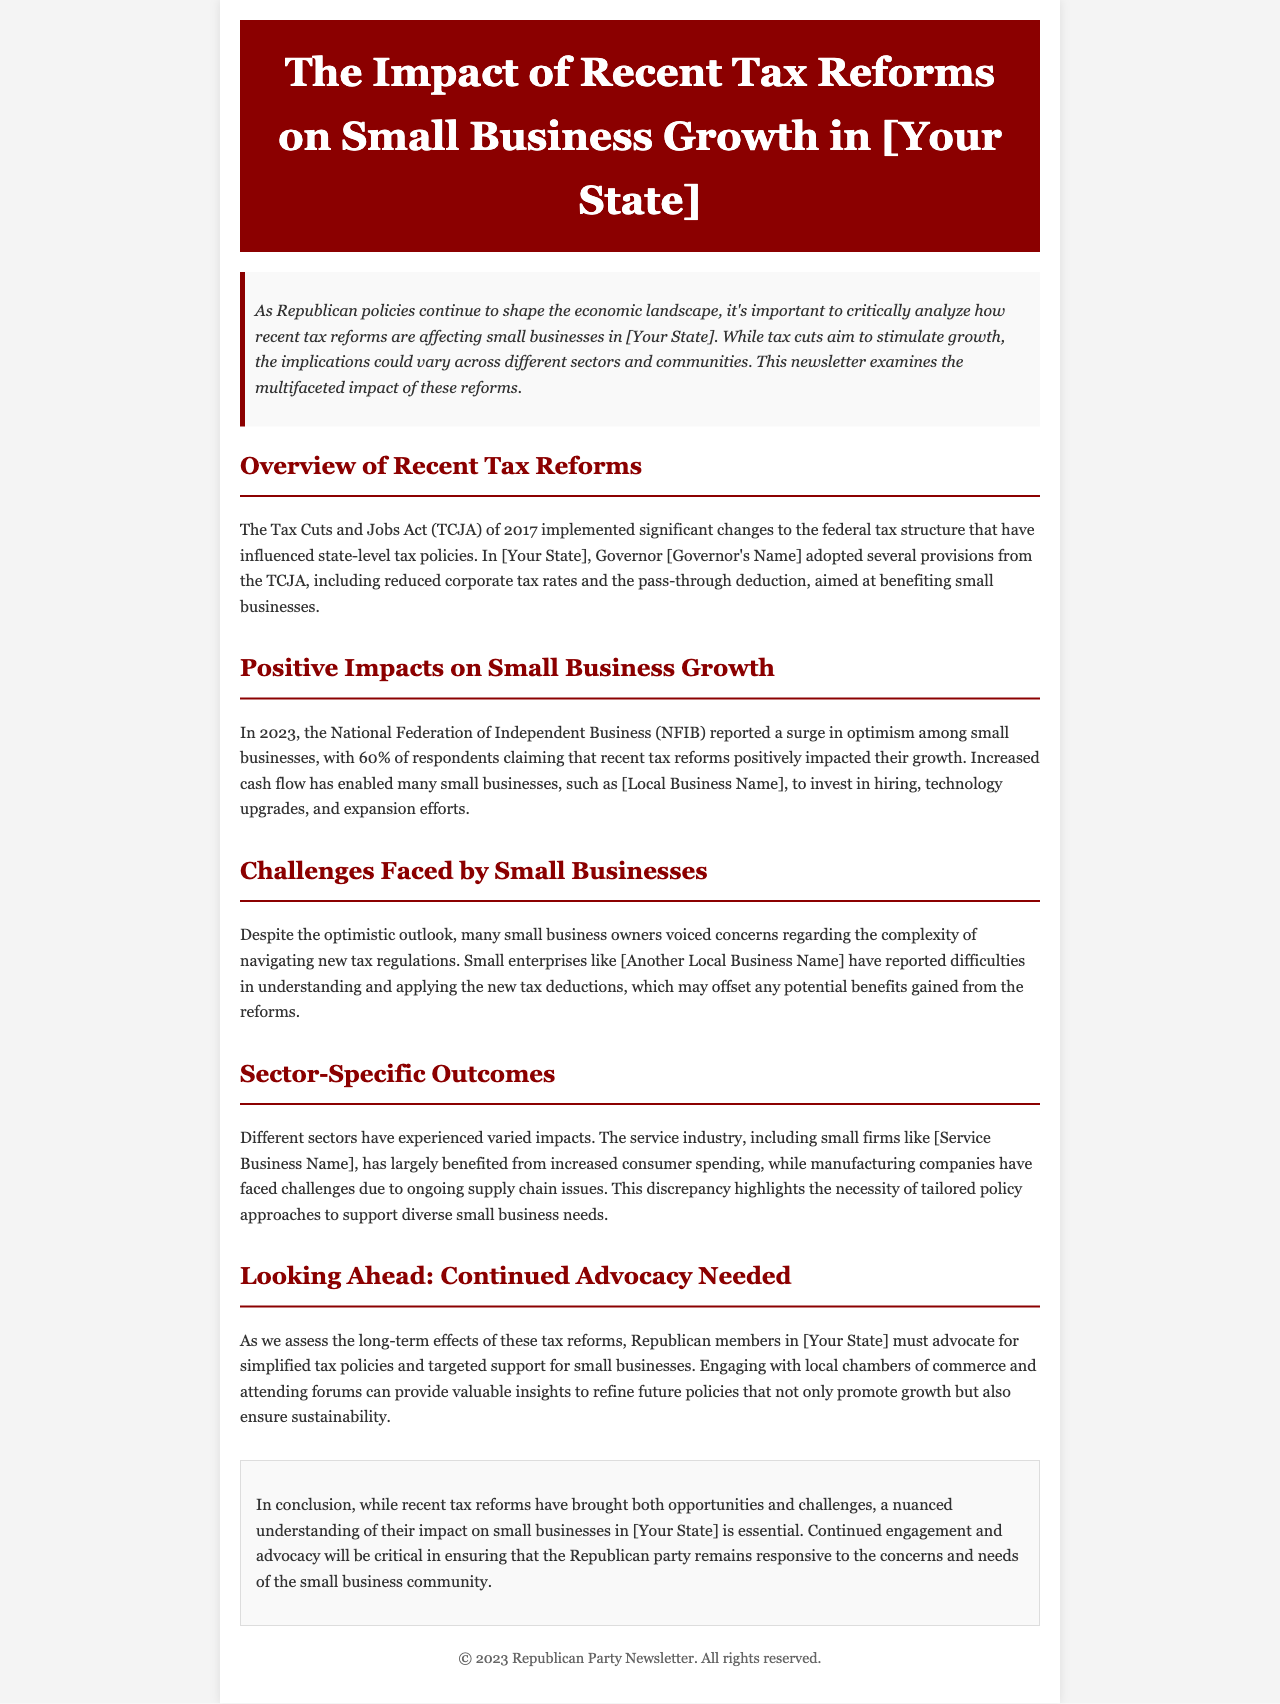What is the title of the newsletter? The title of the newsletter is stated in the header section.
Answer: The Impact of Recent Tax Reforms on Small Business Growth in [Your State] What percentage of small businesses reported a positive impact from tax reforms? The percentage is provided in the positive impacts section of the document.
Answer: 60% Who reported difficulties in understanding new tax deductions? This information is mentioned in the challenges section regarding specific small enterprises.
Answer: [Another Local Business Name] What is a local business example that benefited from tax reforms? An example is given in the positive impacts section.
Answer: [Local Business Name] Which sector faced challenges due to ongoing supply chain issues? The specific sector is mentioned in the sector-specific outcomes section.
Answer: Manufacturing companies What is one suggested action for Republican members regarding tax policies? This recommendation is found in the looking ahead section where future advocacy is discussed.
Answer: Advocate for simplified tax policies What year did the Tax Cuts and Jobs Act come into effect? The year is referenced in the overview of recent tax reforms section.
Answer: 2017 How does the document characterize the service industry's response to tax reforms? The response is discussed in the sector-specific outcomes section.
Answer: Benefited from increased consumer spending 